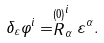Convert formula to latex. <formula><loc_0><loc_0><loc_500><loc_500>\delta _ { \varepsilon } \varphi ^ { i } = \stackrel { ( 0 ) } { R } _ { \alpha } ^ { i } \varepsilon ^ { \alpha } .</formula> 